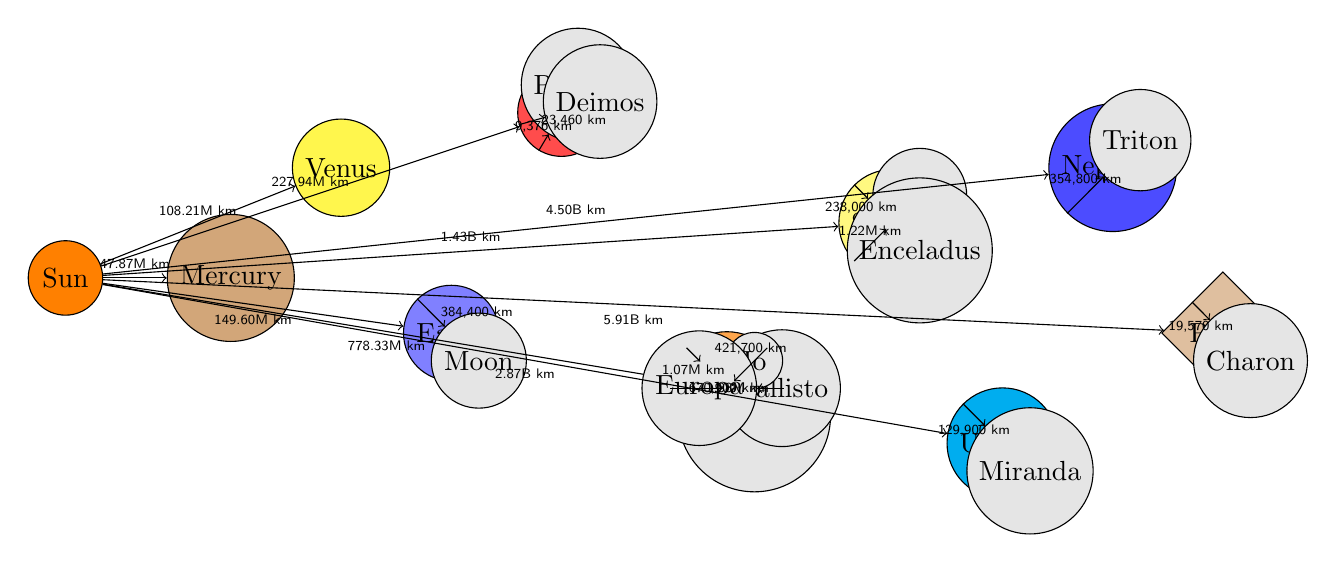What is the distance from the Sun to Jupiter? The diagram shows a line connecting the Sun to Jupiter, labeled with the distance of 778.33 million kilometers. This information is directly depicted in the diagram.
Answer: 778.33M km How many moons does Mars have according to the diagram? In the diagram, Mars has two labeled moons, Phobos and Deimos. The count of these moons can be determined by visually identifying the nodes connected to Mars.
Answer: 2 What color is the planet Neptune represented in the diagram? The diagram uses a specific color fill for each planet. Neptune is filled with a blue shade, as indicated on its node in the diagram.
Answer: Blue What is the distance from Pluto to its moon Charon? The line from Pluto to Charon in the diagram is labeled with 19,570 kilometers, indicating the distance between them, which is visually evident in the diagram.
Answer: 19,570 km Which planet has the moon Titan? The diagram shows Saturn with an arrow pointing to Titan, indicating that Titan is a moon of Saturn. By identifying the arrow connection and the corresponding labels, the relationship can be confirmed.
Answer: Saturn How far is Earth from the Sun compared to Venus? The diagram provides distances of 149.60 million kilometers for Earth and 108.21 million kilometers for Venus, thus a direct comparison can be made through recognition of these values in the diagram.
Answer: Earth is farther than Venus What is the diameter shape used to represent the dwarf planet? The diagram indicates that dwarf planets are represented by a diamond shape, as shown by the node shape category used for Pluto in the diagram.
Answer: Diamond Which planet is located the farthest from the Sun in the diagram? By analyzing the positioning of planets in the diagram, Pluto is placed the farthest from the Sun based on the labeled distance of 5.91 billion kilometers. This positional relationship leads to the conclusion.
Answer: Pluto What is the distance from Jupiter to its moon Ganymede? The distance labeled from Jupiter to Ganymede in the diagram shows it as 1.07 million kilometers, which is indicated by the connecting line between the two nodes.
Answer: 1.07M km 